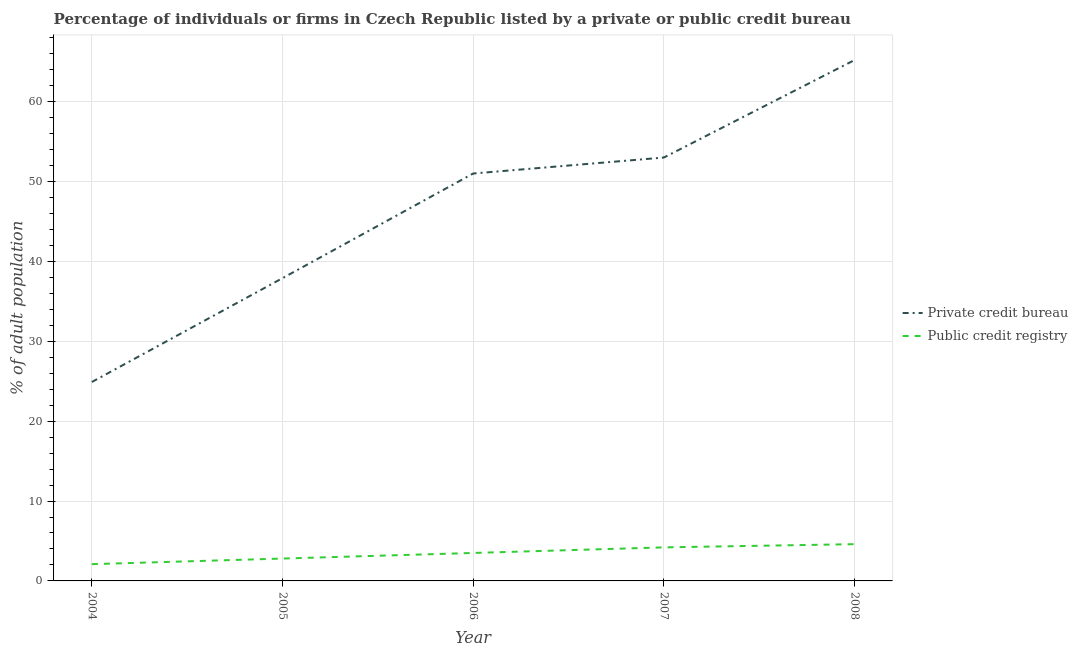How many different coloured lines are there?
Your response must be concise. 2. Does the line corresponding to percentage of firms listed by public credit bureau intersect with the line corresponding to percentage of firms listed by private credit bureau?
Keep it short and to the point. No. What is the percentage of firms listed by private credit bureau in 2004?
Keep it short and to the point. 24.9. Across all years, what is the maximum percentage of firms listed by public credit bureau?
Ensure brevity in your answer.  4.6. In which year was the percentage of firms listed by private credit bureau maximum?
Provide a succinct answer. 2008. What is the total percentage of firms listed by private credit bureau in the graph?
Make the answer very short. 232. What is the difference between the percentage of firms listed by public credit bureau in 2005 and that in 2008?
Give a very brief answer. -1.8. What is the difference between the percentage of firms listed by private credit bureau in 2004 and the percentage of firms listed by public credit bureau in 2007?
Ensure brevity in your answer.  20.7. What is the average percentage of firms listed by private credit bureau per year?
Your answer should be very brief. 46.4. In the year 2005, what is the difference between the percentage of firms listed by private credit bureau and percentage of firms listed by public credit bureau?
Give a very brief answer. 35.1. What is the ratio of the percentage of firms listed by private credit bureau in 2004 to that in 2008?
Offer a terse response. 0.38. What is the difference between the highest and the second highest percentage of firms listed by private credit bureau?
Your answer should be very brief. 12.2. What is the difference between the highest and the lowest percentage of firms listed by private credit bureau?
Provide a succinct answer. 40.3. In how many years, is the percentage of firms listed by public credit bureau greater than the average percentage of firms listed by public credit bureau taken over all years?
Offer a terse response. 3. Is the sum of the percentage of firms listed by private credit bureau in 2004 and 2007 greater than the maximum percentage of firms listed by public credit bureau across all years?
Offer a terse response. Yes. Is the percentage of firms listed by private credit bureau strictly greater than the percentage of firms listed by public credit bureau over the years?
Your answer should be very brief. Yes. Is the percentage of firms listed by public credit bureau strictly less than the percentage of firms listed by private credit bureau over the years?
Provide a short and direct response. Yes. How many years are there in the graph?
Keep it short and to the point. 5. Are the values on the major ticks of Y-axis written in scientific E-notation?
Give a very brief answer. No. Does the graph contain any zero values?
Ensure brevity in your answer.  No. Where does the legend appear in the graph?
Offer a terse response. Center right. How are the legend labels stacked?
Your response must be concise. Vertical. What is the title of the graph?
Ensure brevity in your answer.  Percentage of individuals or firms in Czech Republic listed by a private or public credit bureau. What is the label or title of the Y-axis?
Make the answer very short. % of adult population. What is the % of adult population in Private credit bureau in 2004?
Your answer should be very brief. 24.9. What is the % of adult population in Private credit bureau in 2005?
Provide a short and direct response. 37.9. What is the % of adult population of Public credit registry in 2005?
Your answer should be very brief. 2.8. What is the % of adult population in Public credit registry in 2006?
Provide a succinct answer. 3.5. What is the % of adult population in Private credit bureau in 2008?
Your answer should be compact. 65.2. Across all years, what is the maximum % of adult population of Private credit bureau?
Keep it short and to the point. 65.2. Across all years, what is the maximum % of adult population of Public credit registry?
Ensure brevity in your answer.  4.6. Across all years, what is the minimum % of adult population of Private credit bureau?
Your answer should be very brief. 24.9. Across all years, what is the minimum % of adult population of Public credit registry?
Offer a terse response. 2.1. What is the total % of adult population in Private credit bureau in the graph?
Provide a succinct answer. 232. What is the total % of adult population of Public credit registry in the graph?
Provide a short and direct response. 17.2. What is the difference between the % of adult population of Private credit bureau in 2004 and that in 2005?
Ensure brevity in your answer.  -13. What is the difference between the % of adult population in Public credit registry in 2004 and that in 2005?
Your answer should be very brief. -0.7. What is the difference between the % of adult population in Private credit bureau in 2004 and that in 2006?
Keep it short and to the point. -26.1. What is the difference between the % of adult population of Private credit bureau in 2004 and that in 2007?
Keep it short and to the point. -28.1. What is the difference between the % of adult population in Public credit registry in 2004 and that in 2007?
Offer a terse response. -2.1. What is the difference between the % of adult population in Private credit bureau in 2004 and that in 2008?
Your response must be concise. -40.3. What is the difference between the % of adult population of Private credit bureau in 2005 and that in 2006?
Your answer should be very brief. -13.1. What is the difference between the % of adult population in Public credit registry in 2005 and that in 2006?
Provide a short and direct response. -0.7. What is the difference between the % of adult population of Private credit bureau in 2005 and that in 2007?
Offer a terse response. -15.1. What is the difference between the % of adult population of Private credit bureau in 2005 and that in 2008?
Your answer should be very brief. -27.3. What is the difference between the % of adult population of Public credit registry in 2005 and that in 2008?
Keep it short and to the point. -1.8. What is the difference between the % of adult population of Private credit bureau in 2006 and that in 2007?
Offer a terse response. -2. What is the difference between the % of adult population in Public credit registry in 2006 and that in 2007?
Ensure brevity in your answer.  -0.7. What is the difference between the % of adult population in Private credit bureau in 2007 and that in 2008?
Your response must be concise. -12.2. What is the difference between the % of adult population of Public credit registry in 2007 and that in 2008?
Your answer should be very brief. -0.4. What is the difference between the % of adult population of Private credit bureau in 2004 and the % of adult population of Public credit registry in 2005?
Offer a very short reply. 22.1. What is the difference between the % of adult population in Private credit bureau in 2004 and the % of adult population in Public credit registry in 2006?
Offer a very short reply. 21.4. What is the difference between the % of adult population in Private credit bureau in 2004 and the % of adult population in Public credit registry in 2007?
Your answer should be compact. 20.7. What is the difference between the % of adult population in Private credit bureau in 2004 and the % of adult population in Public credit registry in 2008?
Provide a short and direct response. 20.3. What is the difference between the % of adult population of Private credit bureau in 2005 and the % of adult population of Public credit registry in 2006?
Keep it short and to the point. 34.4. What is the difference between the % of adult population in Private credit bureau in 2005 and the % of adult population in Public credit registry in 2007?
Provide a short and direct response. 33.7. What is the difference between the % of adult population of Private credit bureau in 2005 and the % of adult population of Public credit registry in 2008?
Offer a terse response. 33.3. What is the difference between the % of adult population of Private credit bureau in 2006 and the % of adult population of Public credit registry in 2007?
Offer a terse response. 46.8. What is the difference between the % of adult population of Private credit bureau in 2006 and the % of adult population of Public credit registry in 2008?
Your response must be concise. 46.4. What is the difference between the % of adult population in Private credit bureau in 2007 and the % of adult population in Public credit registry in 2008?
Give a very brief answer. 48.4. What is the average % of adult population in Private credit bureau per year?
Provide a short and direct response. 46.4. What is the average % of adult population of Public credit registry per year?
Provide a succinct answer. 3.44. In the year 2004, what is the difference between the % of adult population in Private credit bureau and % of adult population in Public credit registry?
Offer a very short reply. 22.8. In the year 2005, what is the difference between the % of adult population of Private credit bureau and % of adult population of Public credit registry?
Provide a short and direct response. 35.1. In the year 2006, what is the difference between the % of adult population in Private credit bureau and % of adult population in Public credit registry?
Give a very brief answer. 47.5. In the year 2007, what is the difference between the % of adult population in Private credit bureau and % of adult population in Public credit registry?
Your answer should be very brief. 48.8. In the year 2008, what is the difference between the % of adult population in Private credit bureau and % of adult population in Public credit registry?
Give a very brief answer. 60.6. What is the ratio of the % of adult population of Private credit bureau in 2004 to that in 2005?
Make the answer very short. 0.66. What is the ratio of the % of adult population of Public credit registry in 2004 to that in 2005?
Your response must be concise. 0.75. What is the ratio of the % of adult population in Private credit bureau in 2004 to that in 2006?
Your answer should be compact. 0.49. What is the ratio of the % of adult population of Private credit bureau in 2004 to that in 2007?
Offer a very short reply. 0.47. What is the ratio of the % of adult population of Public credit registry in 2004 to that in 2007?
Ensure brevity in your answer.  0.5. What is the ratio of the % of adult population of Private credit bureau in 2004 to that in 2008?
Ensure brevity in your answer.  0.38. What is the ratio of the % of adult population of Public credit registry in 2004 to that in 2008?
Ensure brevity in your answer.  0.46. What is the ratio of the % of adult population in Private credit bureau in 2005 to that in 2006?
Provide a succinct answer. 0.74. What is the ratio of the % of adult population of Private credit bureau in 2005 to that in 2007?
Offer a terse response. 0.72. What is the ratio of the % of adult population of Public credit registry in 2005 to that in 2007?
Offer a very short reply. 0.67. What is the ratio of the % of adult population of Private credit bureau in 2005 to that in 2008?
Your answer should be very brief. 0.58. What is the ratio of the % of adult population of Public credit registry in 2005 to that in 2008?
Make the answer very short. 0.61. What is the ratio of the % of adult population of Private credit bureau in 2006 to that in 2007?
Offer a terse response. 0.96. What is the ratio of the % of adult population in Private credit bureau in 2006 to that in 2008?
Ensure brevity in your answer.  0.78. What is the ratio of the % of adult population of Public credit registry in 2006 to that in 2008?
Keep it short and to the point. 0.76. What is the ratio of the % of adult population in Private credit bureau in 2007 to that in 2008?
Offer a very short reply. 0.81. What is the ratio of the % of adult population in Public credit registry in 2007 to that in 2008?
Give a very brief answer. 0.91. What is the difference between the highest and the second highest % of adult population of Public credit registry?
Your response must be concise. 0.4. What is the difference between the highest and the lowest % of adult population of Private credit bureau?
Give a very brief answer. 40.3. What is the difference between the highest and the lowest % of adult population of Public credit registry?
Offer a very short reply. 2.5. 